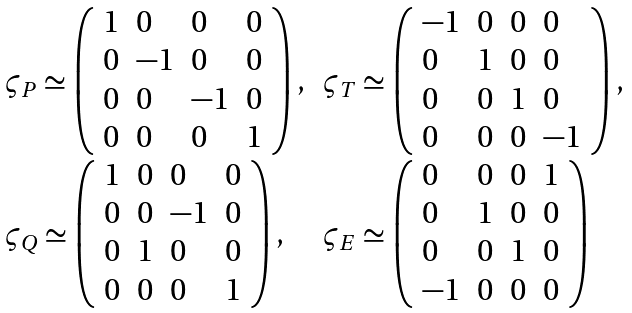Convert formula to latex. <formula><loc_0><loc_0><loc_500><loc_500>\begin{array} { l l } \varsigma _ { P } \simeq \left ( \begin{array} { l l l l } 1 & 0 & 0 & 0 \\ 0 & - 1 & 0 & 0 \\ 0 & 0 & - 1 & 0 \\ 0 & 0 & 0 & 1 \end{array} \right ) , & \varsigma _ { T } \simeq \left ( \begin{array} { l l l l } - 1 & 0 & 0 & 0 \\ 0 & 1 & 0 & 0 \\ 0 & 0 & 1 & 0 \\ 0 & 0 & 0 & - 1 \end{array} \right ) , \\ \varsigma _ { Q } \simeq \left ( \begin{array} { l l l l } 1 & 0 & 0 & 0 \\ 0 & 0 & - 1 & 0 \\ 0 & 1 & 0 & 0 \\ 0 & 0 & 0 & 1 \end{array} \right ) , & \varsigma _ { E } \simeq \left ( \begin{array} { l l l l } 0 & 0 & 0 & 1 \\ 0 & 1 & 0 & 0 \\ 0 & 0 & 1 & 0 \\ - 1 & 0 & 0 & 0 \end{array} \right ) \end{array}</formula> 